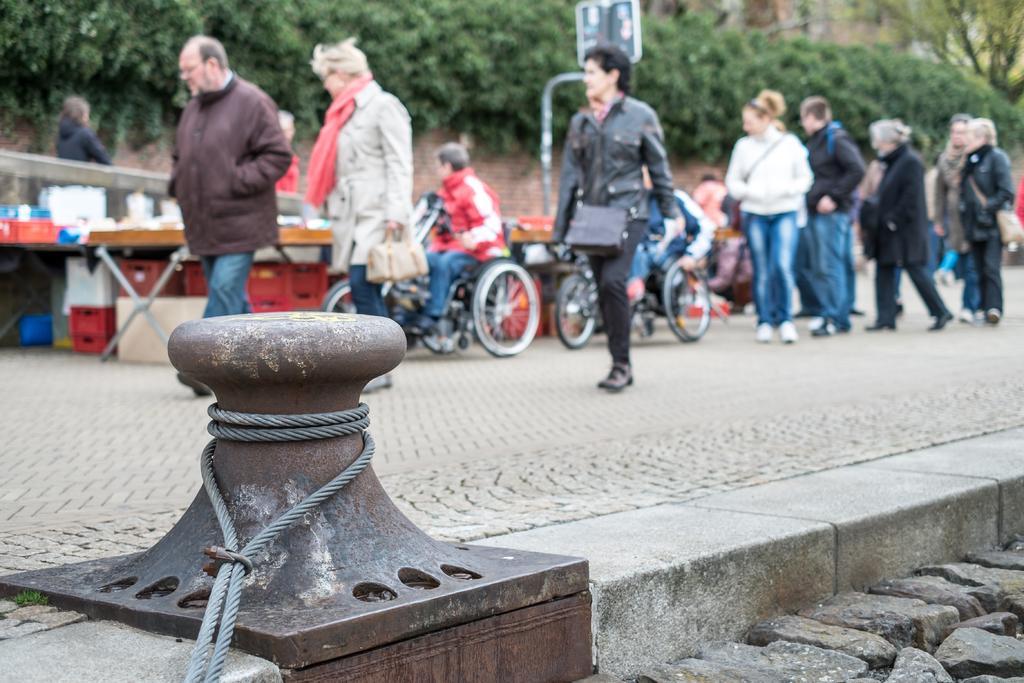Can you describe this image briefly? In this image we can see group of persons standing on the ground. Some persons are carrying bags. Two persons are sitting on wheelchairs. In the background, we can see group of tables, containers placed on the ground, a group of trees and sign board. In the foreground we can see a pole with cable and some rocks. 